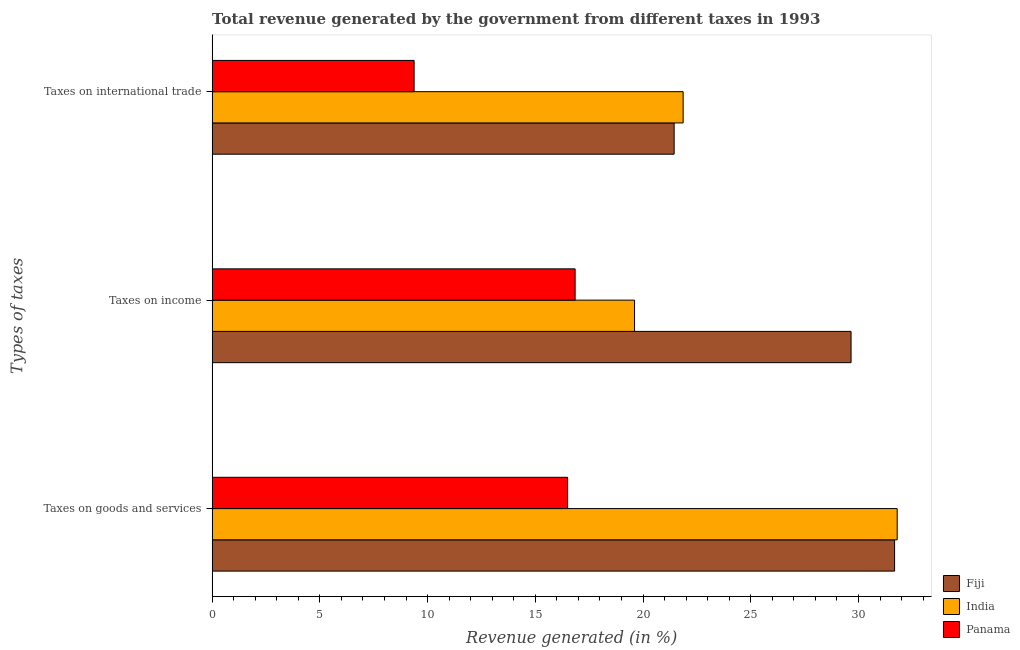How many groups of bars are there?
Ensure brevity in your answer.  3. How many bars are there on the 1st tick from the top?
Offer a terse response. 3. What is the label of the 3rd group of bars from the top?
Ensure brevity in your answer.  Taxes on goods and services. What is the percentage of revenue generated by tax on international trade in India?
Your answer should be very brief. 21.86. Across all countries, what is the maximum percentage of revenue generated by tax on international trade?
Give a very brief answer. 21.86. Across all countries, what is the minimum percentage of revenue generated by taxes on goods and services?
Make the answer very short. 16.5. In which country was the percentage of revenue generated by taxes on goods and services maximum?
Provide a succinct answer. India. In which country was the percentage of revenue generated by tax on international trade minimum?
Your answer should be compact. Panama. What is the total percentage of revenue generated by taxes on goods and services in the graph?
Provide a short and direct response. 79.97. What is the difference between the percentage of revenue generated by tax on international trade in Fiji and that in Panama?
Keep it short and to the point. 12.07. What is the difference between the percentage of revenue generated by taxes on goods and services in Panama and the percentage of revenue generated by taxes on income in India?
Provide a succinct answer. -3.11. What is the average percentage of revenue generated by tax on international trade per country?
Provide a succinct answer. 17.56. What is the difference between the percentage of revenue generated by taxes on income and percentage of revenue generated by tax on international trade in Fiji?
Offer a very short reply. 8.21. What is the ratio of the percentage of revenue generated by tax on international trade in Panama to that in Fiji?
Provide a succinct answer. 0.44. Is the difference between the percentage of revenue generated by tax on international trade in India and Panama greater than the difference between the percentage of revenue generated by taxes on goods and services in India and Panama?
Offer a very short reply. No. What is the difference between the highest and the second highest percentage of revenue generated by taxes on goods and services?
Make the answer very short. 0.12. What is the difference between the highest and the lowest percentage of revenue generated by taxes on goods and services?
Offer a very short reply. 15.3. In how many countries, is the percentage of revenue generated by taxes on goods and services greater than the average percentage of revenue generated by taxes on goods and services taken over all countries?
Give a very brief answer. 2. Is the sum of the percentage of revenue generated by tax on international trade in Fiji and Panama greater than the maximum percentage of revenue generated by taxes on goods and services across all countries?
Your response must be concise. No. What does the 3rd bar from the top in Taxes on goods and services represents?
Your answer should be very brief. Fiji. Is it the case that in every country, the sum of the percentage of revenue generated by taxes on goods and services and percentage of revenue generated by taxes on income is greater than the percentage of revenue generated by tax on international trade?
Your answer should be very brief. Yes. How many bars are there?
Your answer should be very brief. 9. How many countries are there in the graph?
Your answer should be very brief. 3. What is the difference between two consecutive major ticks on the X-axis?
Your answer should be compact. 5. Does the graph contain grids?
Your answer should be compact. No. Where does the legend appear in the graph?
Provide a short and direct response. Bottom right. How are the legend labels stacked?
Keep it short and to the point. Vertical. What is the title of the graph?
Ensure brevity in your answer.  Total revenue generated by the government from different taxes in 1993. Does "Kuwait" appear as one of the legend labels in the graph?
Offer a very short reply. No. What is the label or title of the X-axis?
Ensure brevity in your answer.  Revenue generated (in %). What is the label or title of the Y-axis?
Keep it short and to the point. Types of taxes. What is the Revenue generated (in %) in Fiji in Taxes on goods and services?
Your answer should be very brief. 31.68. What is the Revenue generated (in %) of India in Taxes on goods and services?
Your answer should be very brief. 31.8. What is the Revenue generated (in %) in Panama in Taxes on goods and services?
Your response must be concise. 16.5. What is the Revenue generated (in %) in Fiji in Taxes on income?
Offer a terse response. 29.65. What is the Revenue generated (in %) in India in Taxes on income?
Provide a succinct answer. 19.61. What is the Revenue generated (in %) in Panama in Taxes on income?
Your answer should be compact. 16.85. What is the Revenue generated (in %) in Fiji in Taxes on international trade?
Keep it short and to the point. 21.44. What is the Revenue generated (in %) of India in Taxes on international trade?
Your response must be concise. 21.86. What is the Revenue generated (in %) in Panama in Taxes on international trade?
Offer a very short reply. 9.38. Across all Types of taxes, what is the maximum Revenue generated (in %) of Fiji?
Give a very brief answer. 31.68. Across all Types of taxes, what is the maximum Revenue generated (in %) in India?
Offer a very short reply. 31.8. Across all Types of taxes, what is the maximum Revenue generated (in %) in Panama?
Ensure brevity in your answer.  16.85. Across all Types of taxes, what is the minimum Revenue generated (in %) of Fiji?
Provide a succinct answer. 21.44. Across all Types of taxes, what is the minimum Revenue generated (in %) in India?
Offer a very short reply. 19.61. Across all Types of taxes, what is the minimum Revenue generated (in %) in Panama?
Your answer should be compact. 9.38. What is the total Revenue generated (in %) in Fiji in the graph?
Give a very brief answer. 82.77. What is the total Revenue generated (in %) of India in the graph?
Your response must be concise. 73.26. What is the total Revenue generated (in %) in Panama in the graph?
Offer a very short reply. 42.72. What is the difference between the Revenue generated (in %) of Fiji in Taxes on goods and services and that in Taxes on income?
Offer a terse response. 2.02. What is the difference between the Revenue generated (in %) of India in Taxes on goods and services and that in Taxes on income?
Give a very brief answer. 12.19. What is the difference between the Revenue generated (in %) of Panama in Taxes on goods and services and that in Taxes on income?
Your answer should be compact. -0.35. What is the difference between the Revenue generated (in %) of Fiji in Taxes on goods and services and that in Taxes on international trade?
Your answer should be compact. 10.23. What is the difference between the Revenue generated (in %) in India in Taxes on goods and services and that in Taxes on international trade?
Keep it short and to the point. 9.93. What is the difference between the Revenue generated (in %) in Panama in Taxes on goods and services and that in Taxes on international trade?
Provide a succinct answer. 7.12. What is the difference between the Revenue generated (in %) of Fiji in Taxes on income and that in Taxes on international trade?
Give a very brief answer. 8.21. What is the difference between the Revenue generated (in %) of India in Taxes on income and that in Taxes on international trade?
Your answer should be compact. -2.26. What is the difference between the Revenue generated (in %) in Panama in Taxes on income and that in Taxes on international trade?
Provide a succinct answer. 7.47. What is the difference between the Revenue generated (in %) in Fiji in Taxes on goods and services and the Revenue generated (in %) in India in Taxes on income?
Your answer should be compact. 12.07. What is the difference between the Revenue generated (in %) in Fiji in Taxes on goods and services and the Revenue generated (in %) in Panama in Taxes on income?
Your answer should be compact. 14.83. What is the difference between the Revenue generated (in %) in India in Taxes on goods and services and the Revenue generated (in %) in Panama in Taxes on income?
Give a very brief answer. 14.95. What is the difference between the Revenue generated (in %) in Fiji in Taxes on goods and services and the Revenue generated (in %) in India in Taxes on international trade?
Provide a succinct answer. 9.81. What is the difference between the Revenue generated (in %) of Fiji in Taxes on goods and services and the Revenue generated (in %) of Panama in Taxes on international trade?
Provide a short and direct response. 22.3. What is the difference between the Revenue generated (in %) in India in Taxes on goods and services and the Revenue generated (in %) in Panama in Taxes on international trade?
Make the answer very short. 22.42. What is the difference between the Revenue generated (in %) in Fiji in Taxes on income and the Revenue generated (in %) in India in Taxes on international trade?
Offer a terse response. 7.79. What is the difference between the Revenue generated (in %) in Fiji in Taxes on income and the Revenue generated (in %) in Panama in Taxes on international trade?
Give a very brief answer. 20.28. What is the difference between the Revenue generated (in %) in India in Taxes on income and the Revenue generated (in %) in Panama in Taxes on international trade?
Keep it short and to the point. 10.23. What is the average Revenue generated (in %) in Fiji per Types of taxes?
Your answer should be compact. 27.59. What is the average Revenue generated (in %) of India per Types of taxes?
Offer a terse response. 24.42. What is the average Revenue generated (in %) in Panama per Types of taxes?
Give a very brief answer. 14.24. What is the difference between the Revenue generated (in %) in Fiji and Revenue generated (in %) in India in Taxes on goods and services?
Offer a very short reply. -0.12. What is the difference between the Revenue generated (in %) in Fiji and Revenue generated (in %) in Panama in Taxes on goods and services?
Your answer should be compact. 15.18. What is the difference between the Revenue generated (in %) of India and Revenue generated (in %) of Panama in Taxes on goods and services?
Ensure brevity in your answer.  15.3. What is the difference between the Revenue generated (in %) in Fiji and Revenue generated (in %) in India in Taxes on income?
Ensure brevity in your answer.  10.05. What is the difference between the Revenue generated (in %) in Fiji and Revenue generated (in %) in Panama in Taxes on income?
Your answer should be very brief. 12.81. What is the difference between the Revenue generated (in %) in India and Revenue generated (in %) in Panama in Taxes on income?
Keep it short and to the point. 2.76. What is the difference between the Revenue generated (in %) of Fiji and Revenue generated (in %) of India in Taxes on international trade?
Your answer should be very brief. -0.42. What is the difference between the Revenue generated (in %) of Fiji and Revenue generated (in %) of Panama in Taxes on international trade?
Your answer should be compact. 12.07. What is the difference between the Revenue generated (in %) in India and Revenue generated (in %) in Panama in Taxes on international trade?
Make the answer very short. 12.49. What is the ratio of the Revenue generated (in %) in Fiji in Taxes on goods and services to that in Taxes on income?
Provide a succinct answer. 1.07. What is the ratio of the Revenue generated (in %) of India in Taxes on goods and services to that in Taxes on income?
Ensure brevity in your answer.  1.62. What is the ratio of the Revenue generated (in %) in Panama in Taxes on goods and services to that in Taxes on income?
Your answer should be very brief. 0.98. What is the ratio of the Revenue generated (in %) in Fiji in Taxes on goods and services to that in Taxes on international trade?
Keep it short and to the point. 1.48. What is the ratio of the Revenue generated (in %) in India in Taxes on goods and services to that in Taxes on international trade?
Keep it short and to the point. 1.45. What is the ratio of the Revenue generated (in %) of Panama in Taxes on goods and services to that in Taxes on international trade?
Your response must be concise. 1.76. What is the ratio of the Revenue generated (in %) in Fiji in Taxes on income to that in Taxes on international trade?
Ensure brevity in your answer.  1.38. What is the ratio of the Revenue generated (in %) of India in Taxes on income to that in Taxes on international trade?
Your response must be concise. 0.9. What is the ratio of the Revenue generated (in %) in Panama in Taxes on income to that in Taxes on international trade?
Offer a very short reply. 1.8. What is the difference between the highest and the second highest Revenue generated (in %) in Fiji?
Make the answer very short. 2.02. What is the difference between the highest and the second highest Revenue generated (in %) of India?
Keep it short and to the point. 9.93. What is the difference between the highest and the second highest Revenue generated (in %) in Panama?
Your answer should be very brief. 0.35. What is the difference between the highest and the lowest Revenue generated (in %) of Fiji?
Offer a very short reply. 10.23. What is the difference between the highest and the lowest Revenue generated (in %) of India?
Make the answer very short. 12.19. What is the difference between the highest and the lowest Revenue generated (in %) of Panama?
Provide a succinct answer. 7.47. 